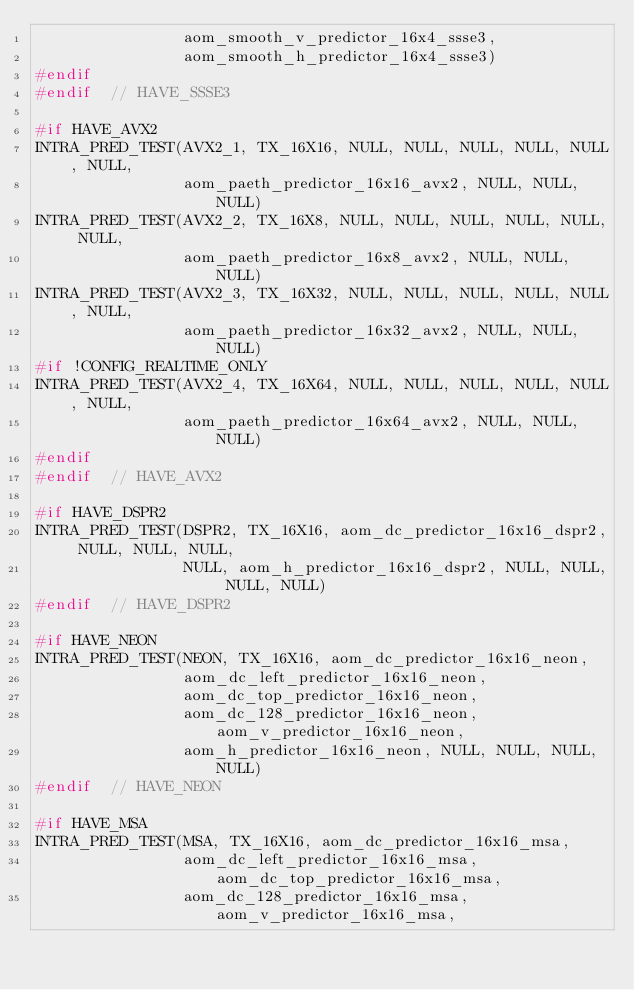Convert code to text. <code><loc_0><loc_0><loc_500><loc_500><_C++_>                aom_smooth_v_predictor_16x4_ssse3,
                aom_smooth_h_predictor_16x4_ssse3)
#endif
#endif  // HAVE_SSSE3

#if HAVE_AVX2
INTRA_PRED_TEST(AVX2_1, TX_16X16, NULL, NULL, NULL, NULL, NULL, NULL,
                aom_paeth_predictor_16x16_avx2, NULL, NULL, NULL)
INTRA_PRED_TEST(AVX2_2, TX_16X8, NULL, NULL, NULL, NULL, NULL, NULL,
                aom_paeth_predictor_16x8_avx2, NULL, NULL, NULL)
INTRA_PRED_TEST(AVX2_3, TX_16X32, NULL, NULL, NULL, NULL, NULL, NULL,
                aom_paeth_predictor_16x32_avx2, NULL, NULL, NULL)
#if !CONFIG_REALTIME_ONLY
INTRA_PRED_TEST(AVX2_4, TX_16X64, NULL, NULL, NULL, NULL, NULL, NULL,
                aom_paeth_predictor_16x64_avx2, NULL, NULL, NULL)
#endif
#endif  // HAVE_AVX2

#if HAVE_DSPR2
INTRA_PRED_TEST(DSPR2, TX_16X16, aom_dc_predictor_16x16_dspr2, NULL, NULL, NULL,
                NULL, aom_h_predictor_16x16_dspr2, NULL, NULL, NULL, NULL)
#endif  // HAVE_DSPR2

#if HAVE_NEON
INTRA_PRED_TEST(NEON, TX_16X16, aom_dc_predictor_16x16_neon,
                aom_dc_left_predictor_16x16_neon,
                aom_dc_top_predictor_16x16_neon,
                aom_dc_128_predictor_16x16_neon, aom_v_predictor_16x16_neon,
                aom_h_predictor_16x16_neon, NULL, NULL, NULL, NULL)
#endif  // HAVE_NEON

#if HAVE_MSA
INTRA_PRED_TEST(MSA, TX_16X16, aom_dc_predictor_16x16_msa,
                aom_dc_left_predictor_16x16_msa, aom_dc_top_predictor_16x16_msa,
                aom_dc_128_predictor_16x16_msa, aom_v_predictor_16x16_msa,</code> 